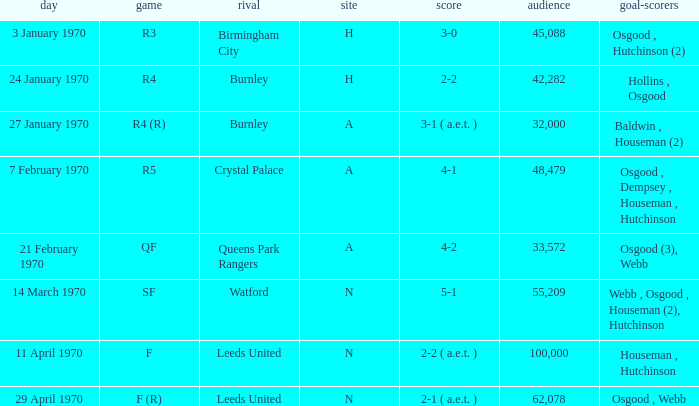What is the highest attendance at a game with a result of 5-1? 55209.0. 